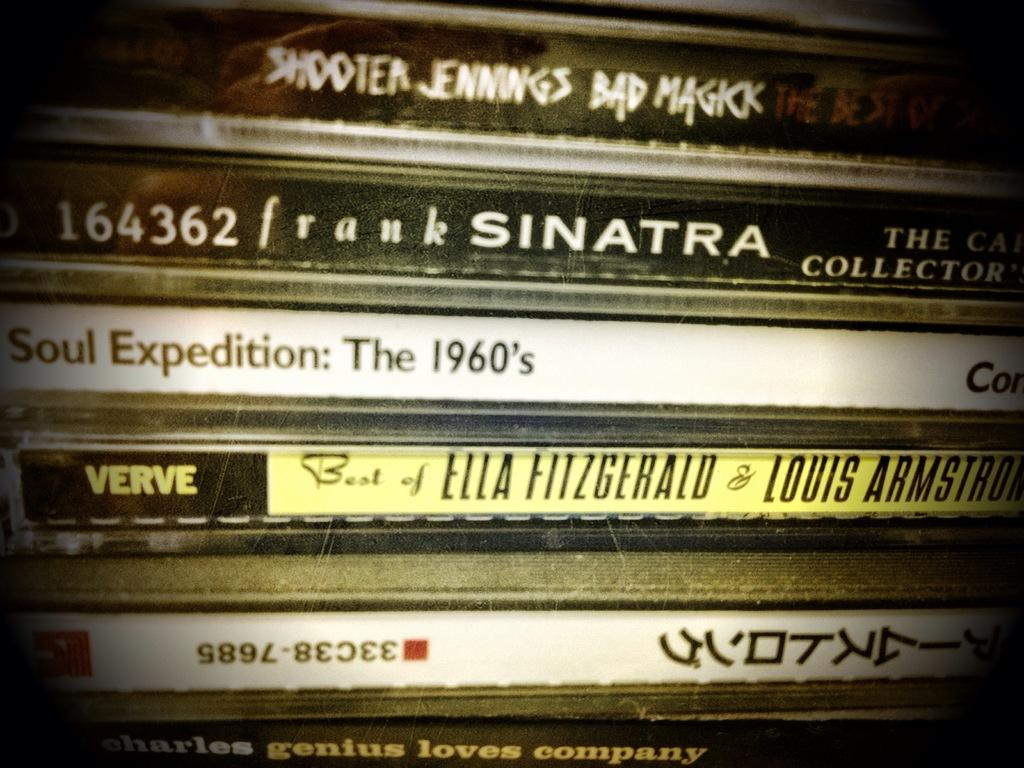<image>
Describe the image concisely. several cases of different musical albums including a frank sinatra collection. 